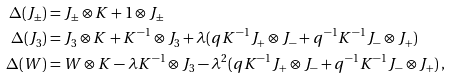Convert formula to latex. <formula><loc_0><loc_0><loc_500><loc_500>\Delta ( J _ { \pm } ) & = J _ { \pm } \otimes K + 1 \otimes J _ { \pm } \\ \Delta ( J _ { 3 } ) & = J _ { 3 } \otimes K + K ^ { - 1 } \otimes J _ { 3 } + \lambda ( q K ^ { - 1 } J _ { + } \otimes J _ { - } + q ^ { - 1 } K ^ { - 1 } J _ { - } \otimes J _ { + } ) \\ \Delta ( W ) & = W \otimes K - \lambda K ^ { - 1 } \otimes J _ { 3 } - \lambda ^ { 2 } ( q K ^ { - 1 } J _ { + } \otimes J _ { - } + q ^ { - 1 } K ^ { - 1 } J _ { - } \otimes J _ { + } ) \, ,</formula> 